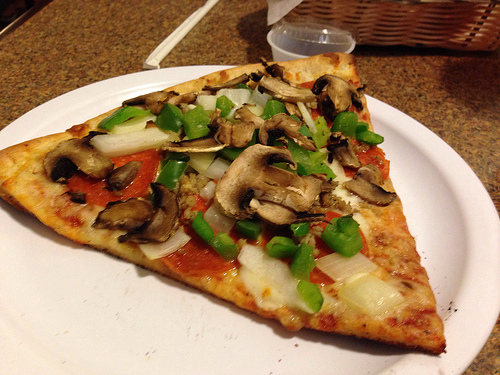Imagine if the toppings on this pizza could come to life. What kind of adventure would they embark on? In the whimsical land of Pizzagonia, the toppings of the pizza—Mushroom Max, Bell Pepper Bella, Onion Olly, and Pepperoni Pete—embark on a grand adventure to save their world from the dreaded Burnt Edge Fiends. Along the way, they navigate through the Cheesy Hills and cross the Doughy Plains, using their unique ingredients traits to solve puzzles and defeat enemies. They ultimately discover that their unity and flavors combine to create the ultimate culinary harmony, restoring peace and balance to Pizzagonia. Describe the culinary exploration a food blogger might experience when tasting this pizza. As the food blogger takes their first bite, the medley of flavors offers an exquisite symphony for the taste buds. The sautéed mushrooms provide an earthy, umami kick that blends perfectly with the fresh, slightly crunchy green bell peppers. The onions add a sweet, caramelized depth that contrasts beautifully with the smoky, spicy notes of the pepperoni. The crispy yet tender crust serves as the ideal canvas for the toppings, bringing harmony to each bite. This pizza is truly a gastronomic journey, evoking memories of rustic kitchens and family gatherings. 